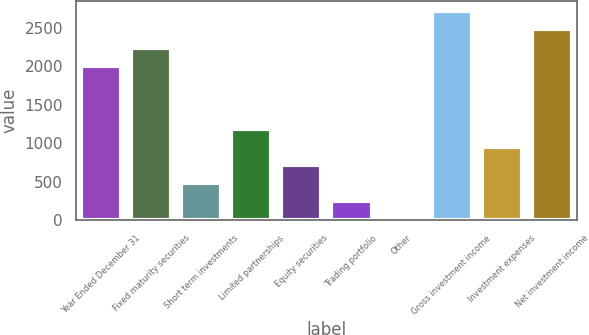<chart> <loc_0><loc_0><loc_500><loc_500><bar_chart><fcel>Year Ended December 31<fcel>Fixed maturity securities<fcel>Short term investments<fcel>Limited partnerships<fcel>Equity securities<fcel>Trading portfolio<fcel>Other<fcel>Gross investment income<fcel>Investment expenses<fcel>Net investment income<nl><fcel>2010<fcel>2246<fcel>482<fcel>1190<fcel>718<fcel>246<fcel>10<fcel>2718<fcel>954<fcel>2482<nl></chart> 